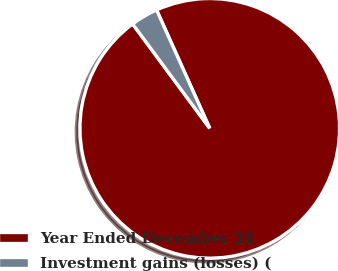Convert chart. <chart><loc_0><loc_0><loc_500><loc_500><pie_chart><fcel>Year Ended December 31<fcel>Investment gains (losses) (<nl><fcel>96.6%<fcel>3.4%<nl></chart> 